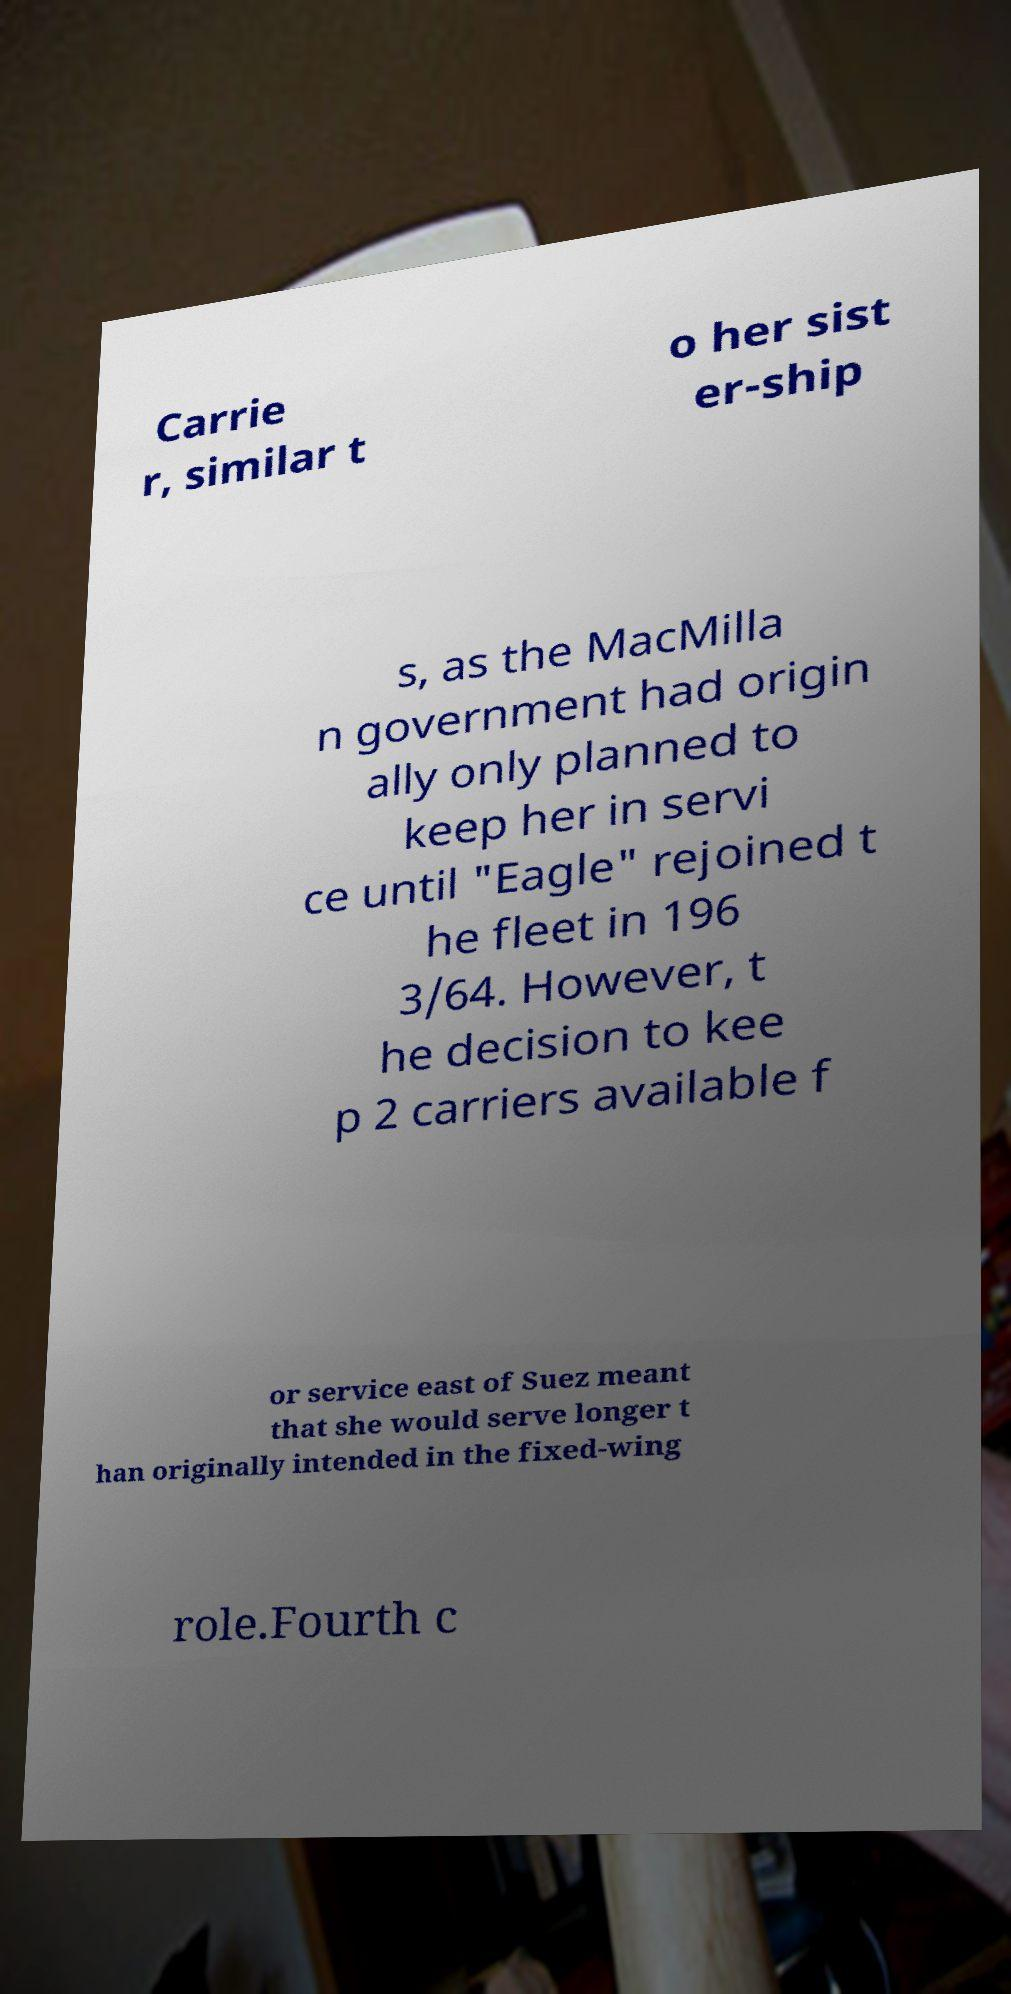Could you extract and type out the text from this image? Carrie r, similar t o her sist er-ship s, as the MacMilla n government had origin ally only planned to keep her in servi ce until "Eagle" rejoined t he fleet in 196 3/64. However, t he decision to kee p 2 carriers available f or service east of Suez meant that she would serve longer t han originally intended in the fixed-wing role.Fourth c 